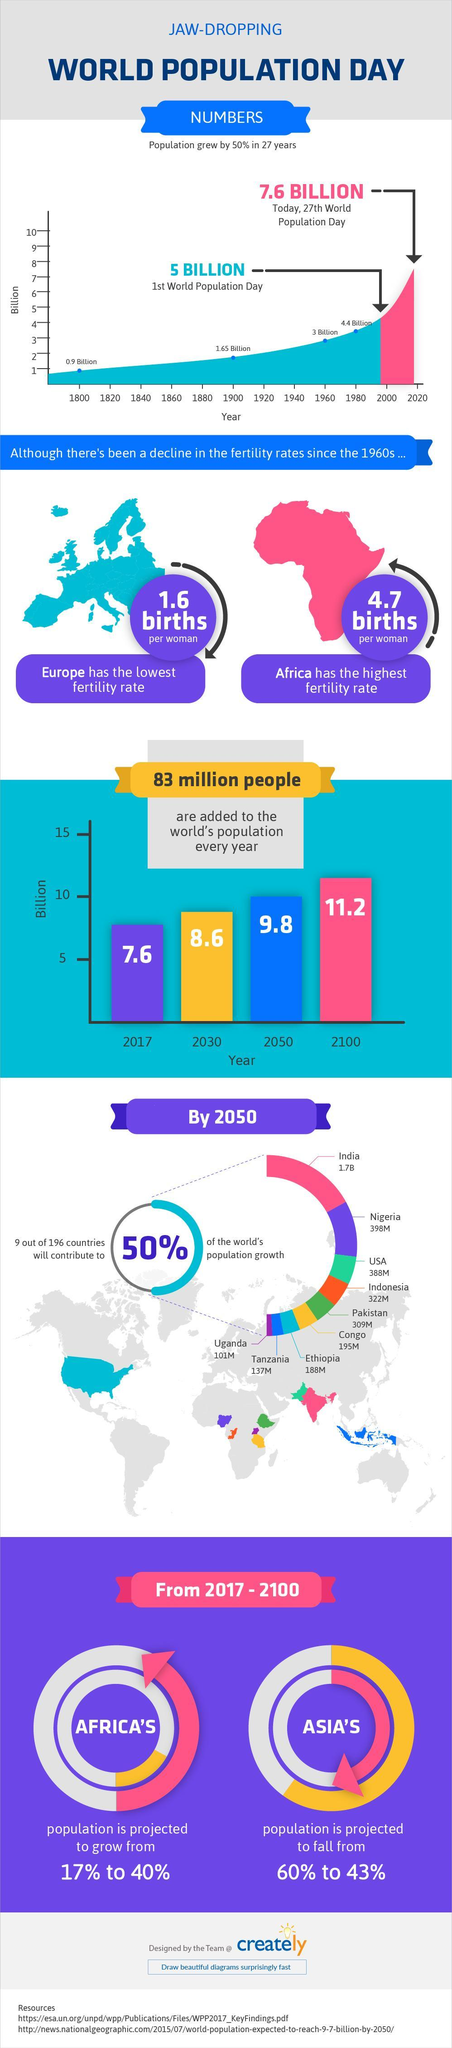What is the population of Nigeria and the USA, taken together by 2050?
Answer the question with a short phrase. 786M What is the percentage increase in the population of Africa? 23% What is the population of Uganda and Tanzania, taken together by 2050? 238M What is the population of Ethiopia and Congo, taken together by 2050? 383M What is the percentage decrease in the population of Asia? 17% 